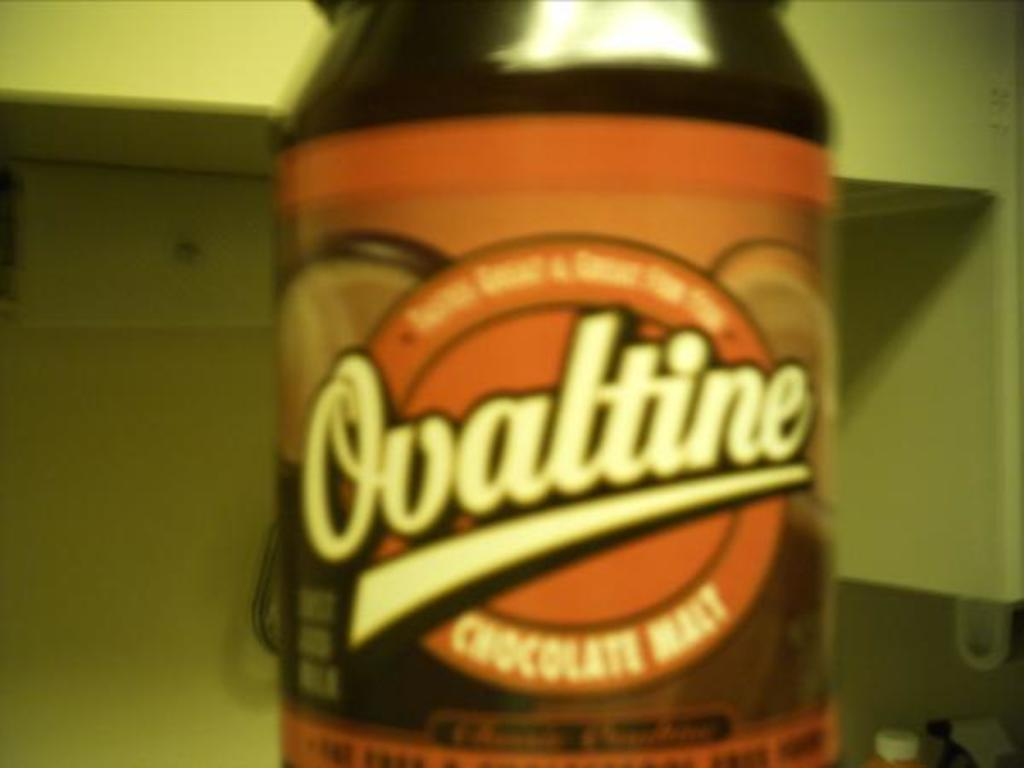<image>
Describe the image concisely. A chocolate flavored condiment from the brand Ovaltine is in the kitchen. 